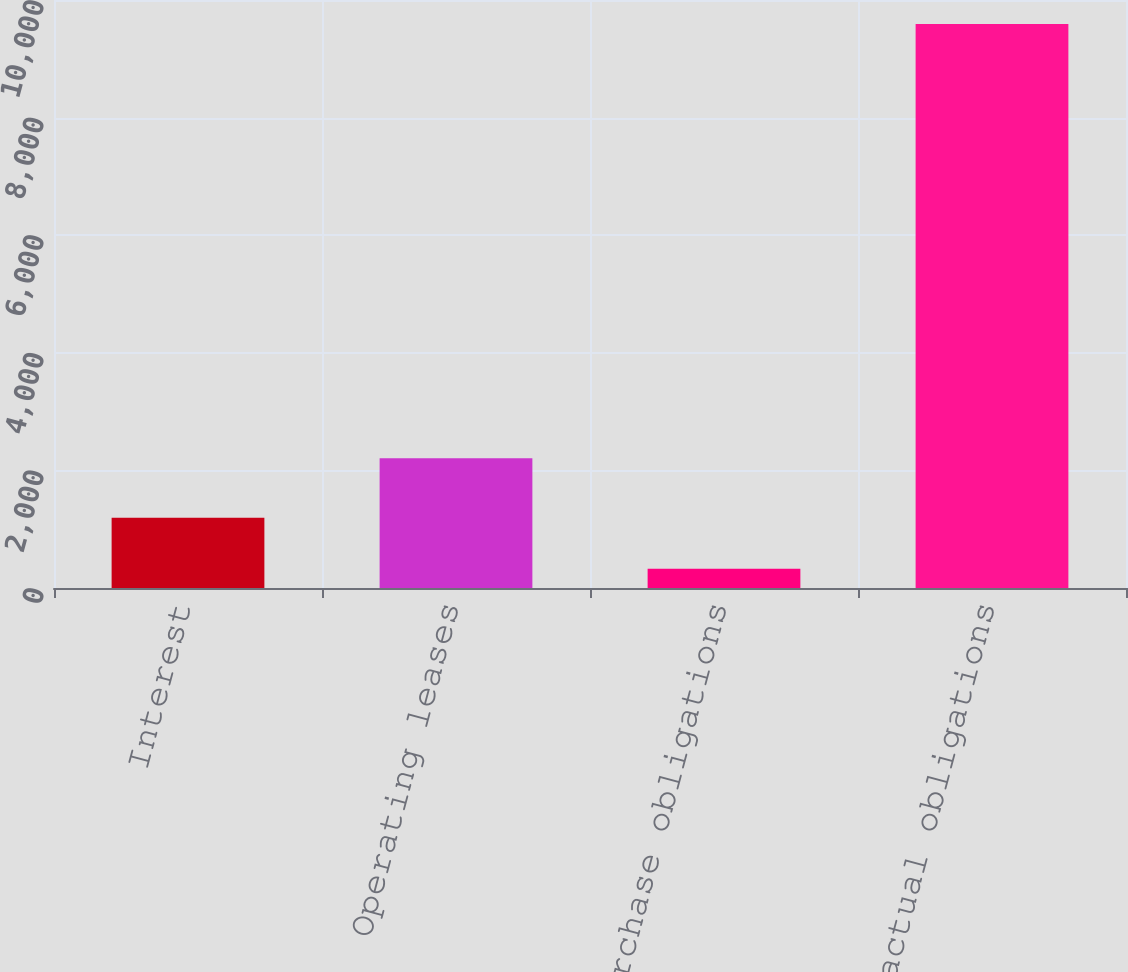Convert chart to OTSL. <chart><loc_0><loc_0><loc_500><loc_500><bar_chart><fcel>Interest<fcel>Operating leases<fcel>Purchase obligations<fcel>Total contractual obligations<nl><fcel>1195<fcel>2206<fcel>327<fcel>9590<nl></chart> 